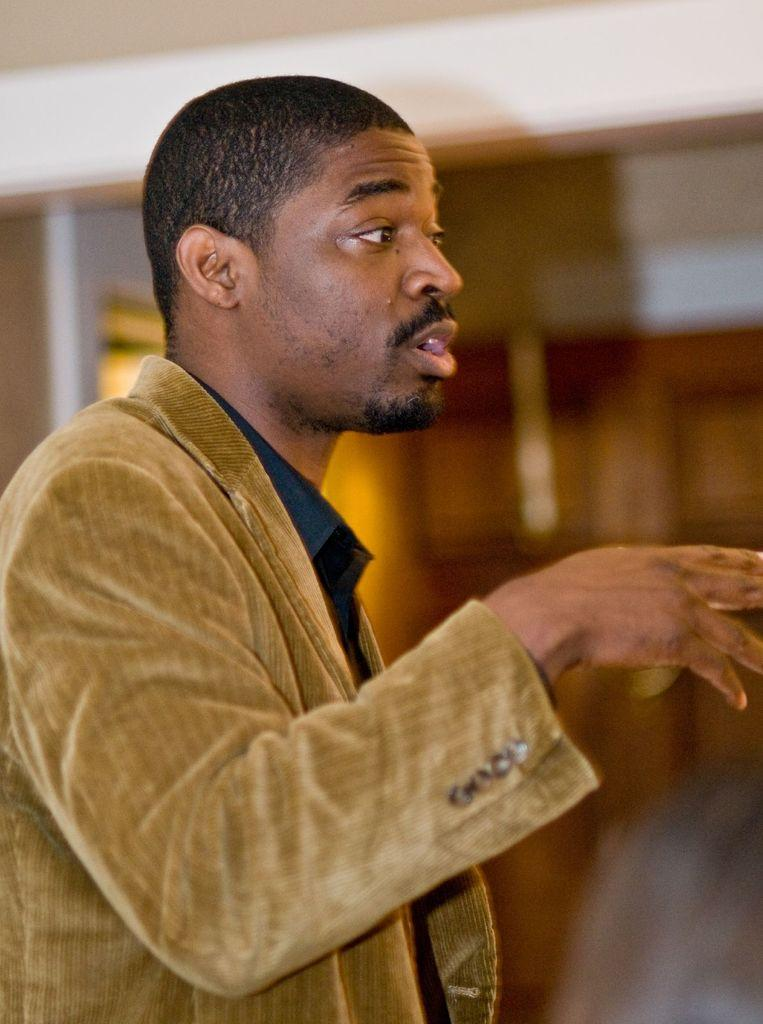Who or what is present in the image? There is a person in the image. What is the person wearing? The person is wearing a jacket. What type of ground is visible in the image? There is no ground visible in the image; it only shows a person wearing a jacket. 